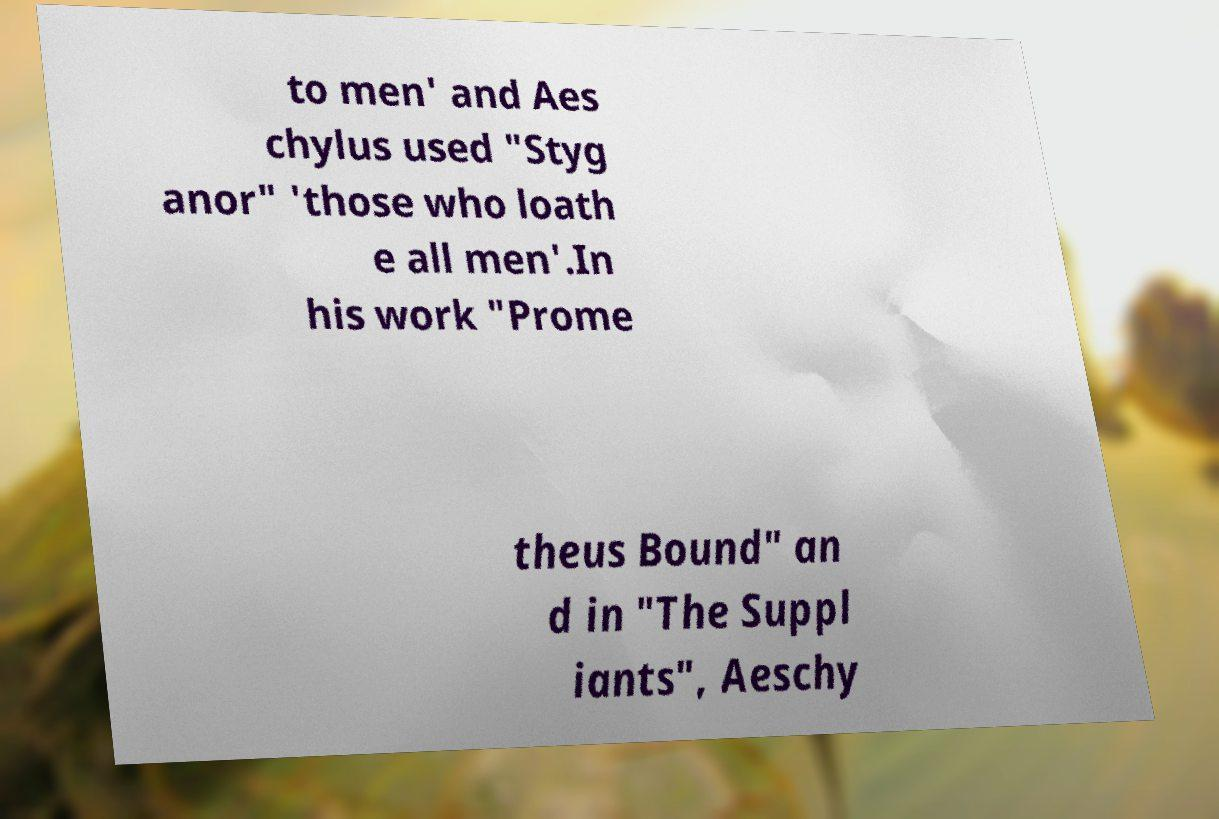Can you read and provide the text displayed in the image?This photo seems to have some interesting text. Can you extract and type it out for me? to men' and Aes chylus used "Styg anor" 'those who loath e all men'.In his work "Prome theus Bound" an d in "The Suppl iants", Aeschy 